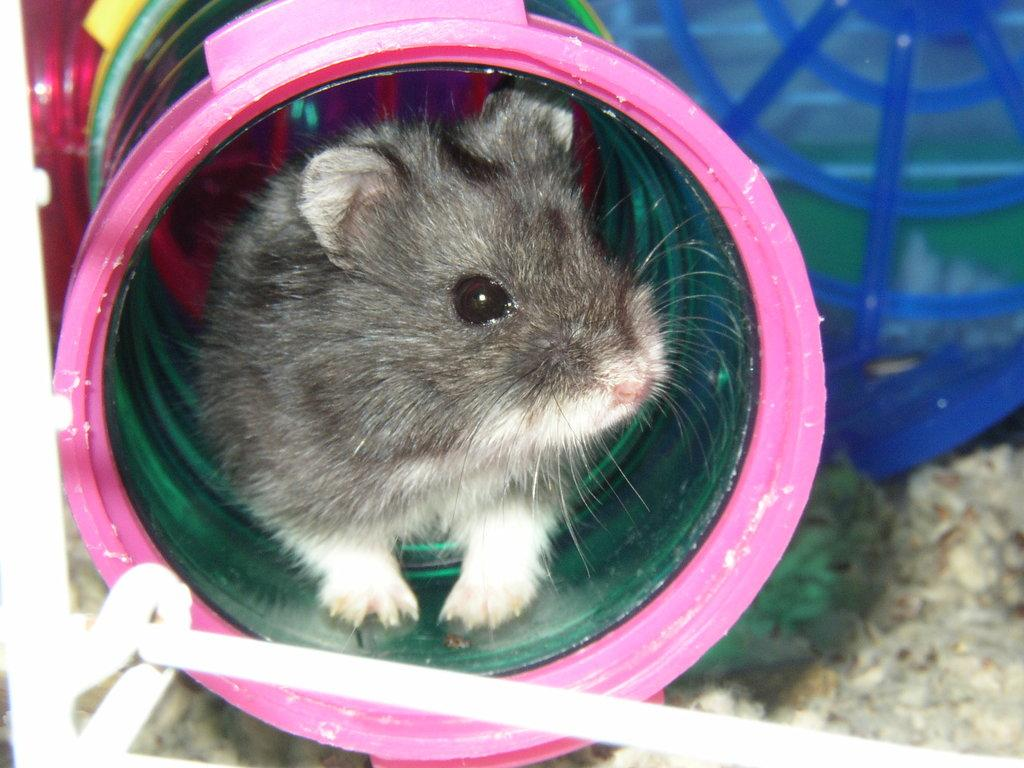What animal is the main subject of the picture? There is a mouse in the picture. Where is the mouse located in the picture? The mouse is in the middle of the picture. What is the mouse's environment like in the picture? The mouse is in a small tunnel. What colors can be seen on the mouse in the picture? The mouse is grey and white in color. What type of calculator is being used by the mouse in the picture? There is no calculator present in the picture; it features a mouse in a small tunnel. 